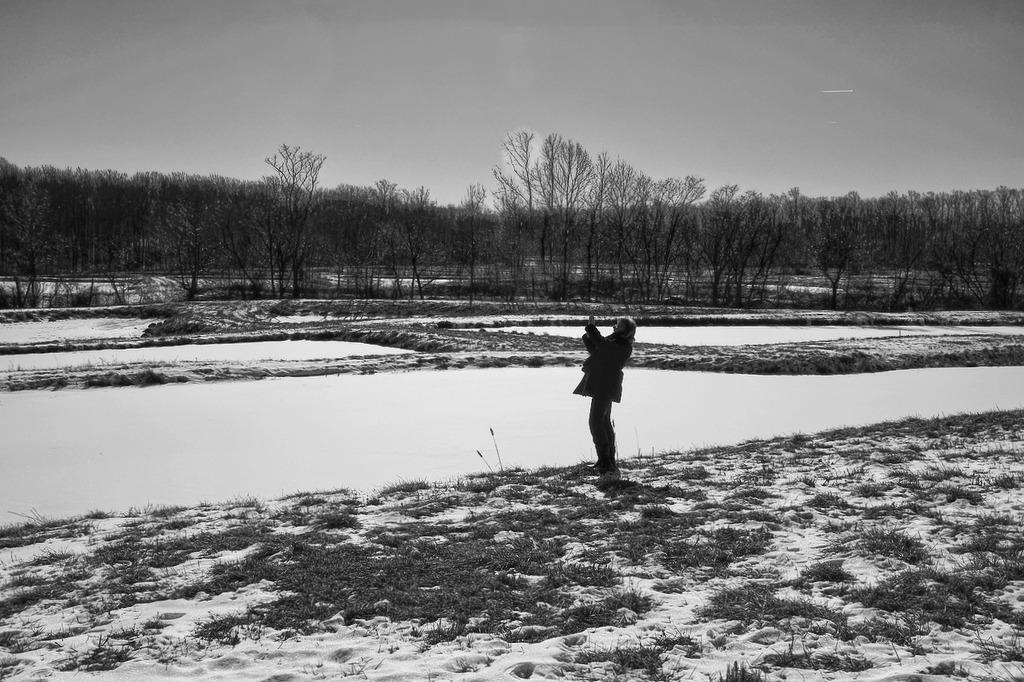What is the main subject of the image? The main subject of the image is a black and white photograph of a woman. What is the woman doing in the image? The woman is standing on the ground and taking photographs. What can be seen in the background of the image? There is a small water pond and many dry trees in the background. What type of food is the woman eating in the image? There is no food present in the image; the woman is taking photographs. How many brothers does the woman have in the image? There is no information about the woman's brothers in the image. 